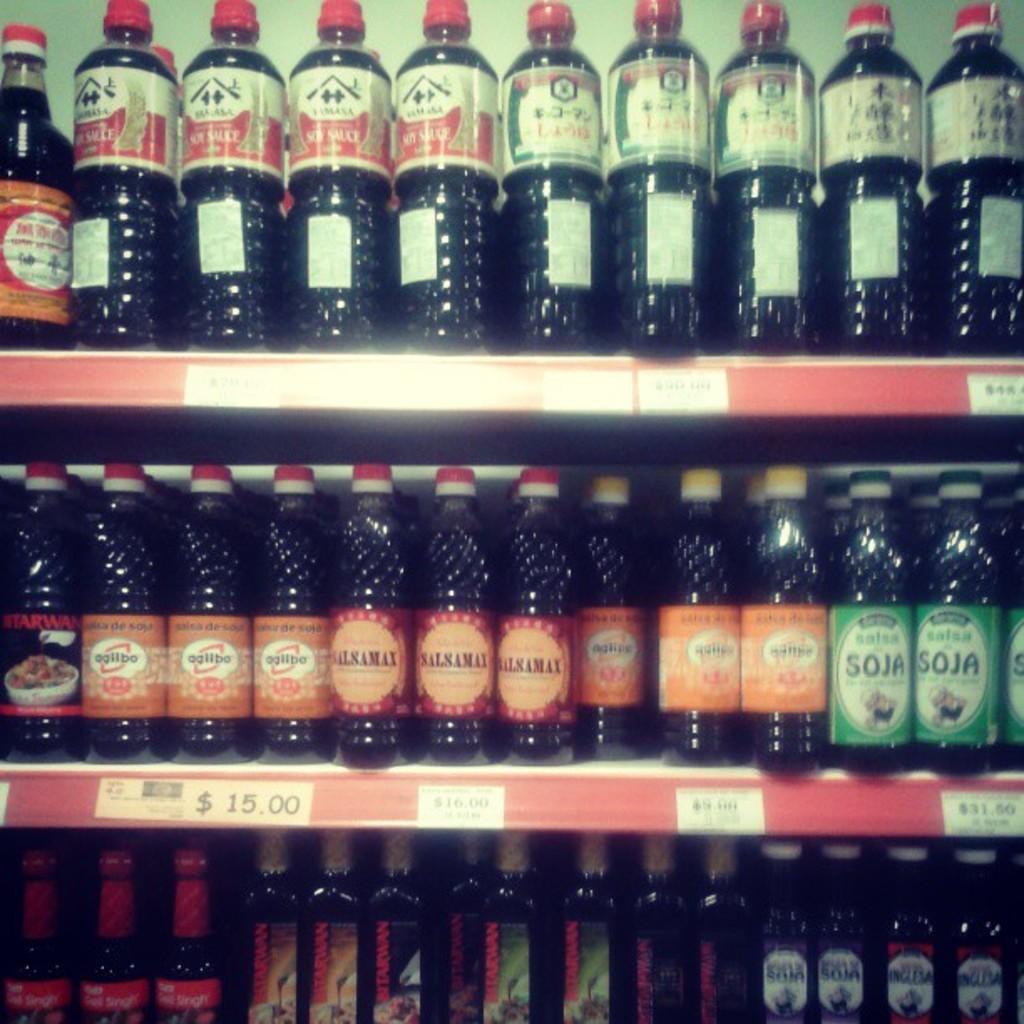How much does the orange label product on the left of the middle shelf cost?
Ensure brevity in your answer.  15.00. What does the green bottle say?
Provide a short and direct response. Soja. 